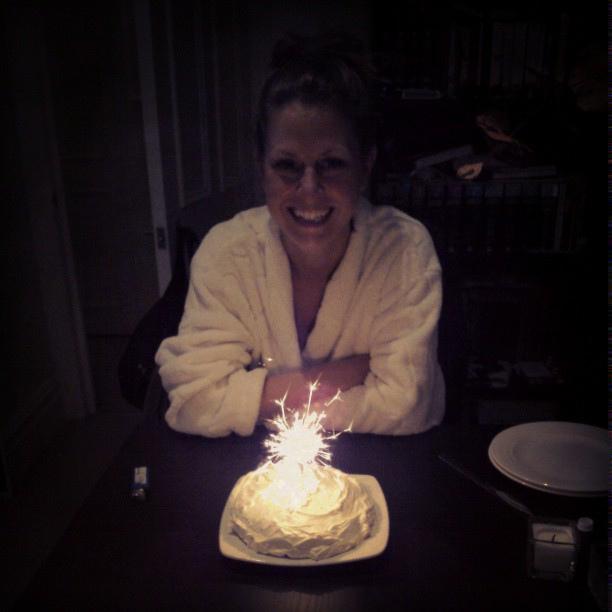How many people are there?
Write a very short answer. 1. What kind of frosting is on the cake?
Quick response, please. Vanilla. Is the woman wearing a necklace?
Short answer required. No. What color is the cake?
Concise answer only. White. What kind of icing is on the cake?
Answer briefly. Vanilla. What is on the table?
Keep it brief. Cake. What kind of cake is there?
Be succinct. Birthday. Do you think this plate was expensive?
Short answer required. No. How many different candies are visible?
Quick response, please. 1. Is the woman happy?
Short answer required. Yes. How many candles are on the cake?
Concise answer only. 1. What is the girl doing behind the cakes?
Quick response, please. Smiling. How many children are beside the woman blowing out the candles?
Concise answer only. 0. What color are the candles?
Write a very short answer. White. Is it sunny outside?
Keep it brief. No. Why are there candles on the cake?
Give a very brief answer. Birthday. Is the woman overjoyed?
Short answer required. Yes. What's on top of the cake?
Give a very brief answer. Sparkler. Is the woman trying to blow out the candles?
Keep it brief. No. What kind of cake is on the plate e?
Keep it brief. Birthday. What is the event?
Answer briefly. Birthday. What's the lighting?
Answer briefly. Candle. How close was her face to the cake?
Concise answer only. Close. What age is being celebrated?
Be succinct. 50. How many candles are lit?
Answer briefly. 1. How many plates are there?
Concise answer only. 3. Is anything in the background?
Short answer required. Yes. What does it appear they are celebrating?
Short answer required. Birthday. Of what ethnicity does this woman appear?
Concise answer only. White. How old is the birthday person?
Give a very brief answer. 30. What number of sparklers are in this cake?
Give a very brief answer. 1. Was the picture taken during the daytime?
Give a very brief answer. No. 